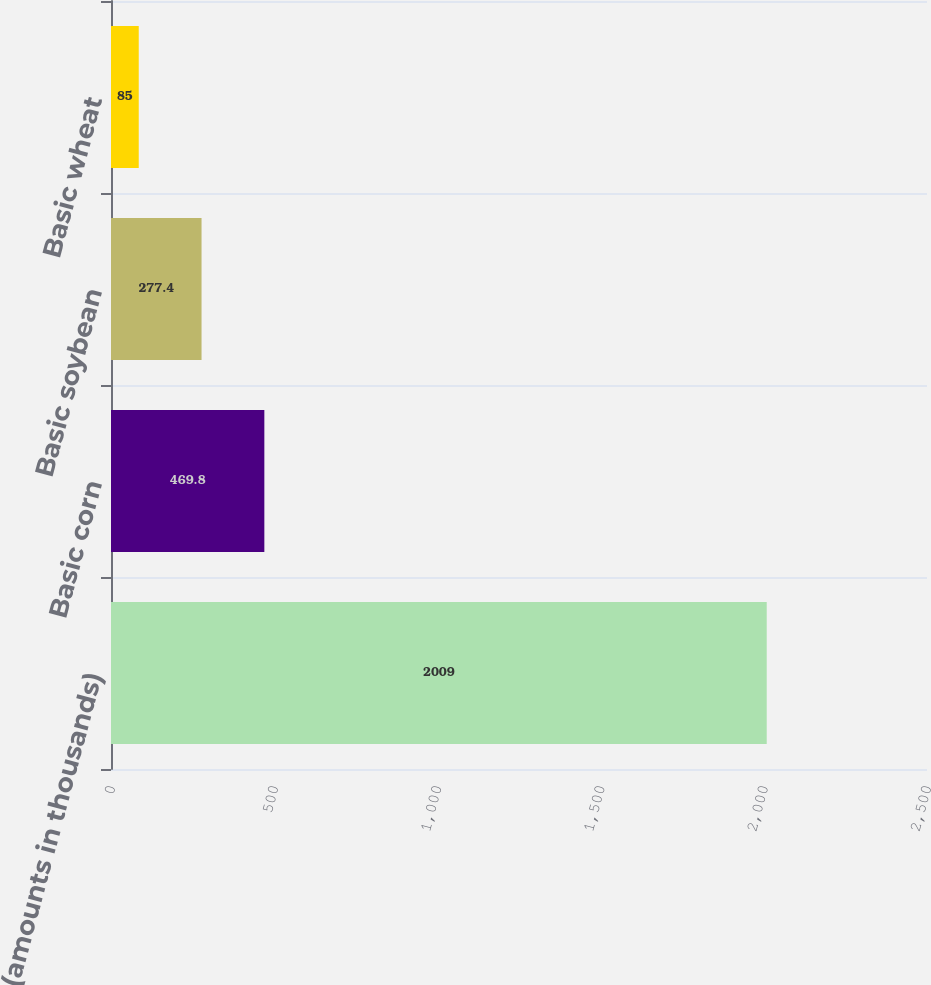<chart> <loc_0><loc_0><loc_500><loc_500><bar_chart><fcel>(amounts in thousands)<fcel>Basic corn<fcel>Basic soybean<fcel>Basic wheat<nl><fcel>2009<fcel>469.8<fcel>277.4<fcel>85<nl></chart> 